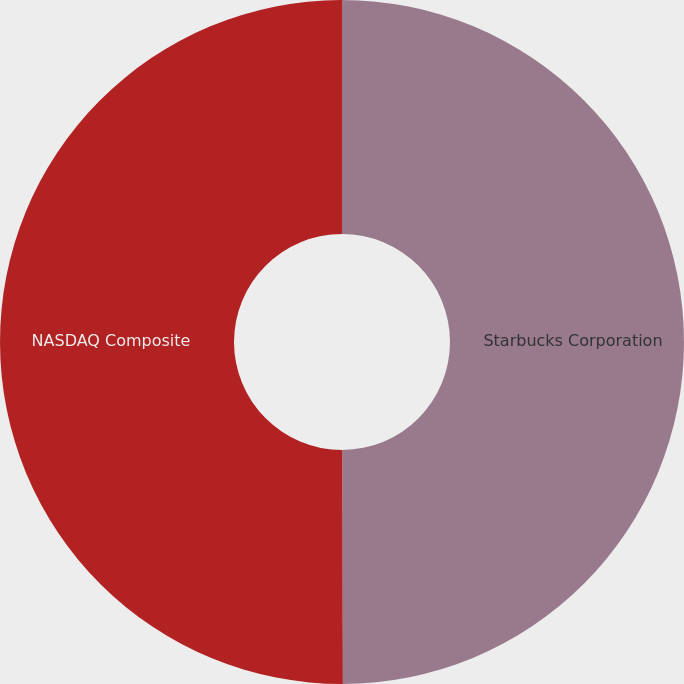Convert chart to OTSL. <chart><loc_0><loc_0><loc_500><loc_500><pie_chart><fcel>Starbucks Corporation<fcel>NASDAQ Composite<nl><fcel>49.96%<fcel>50.04%<nl></chart> 